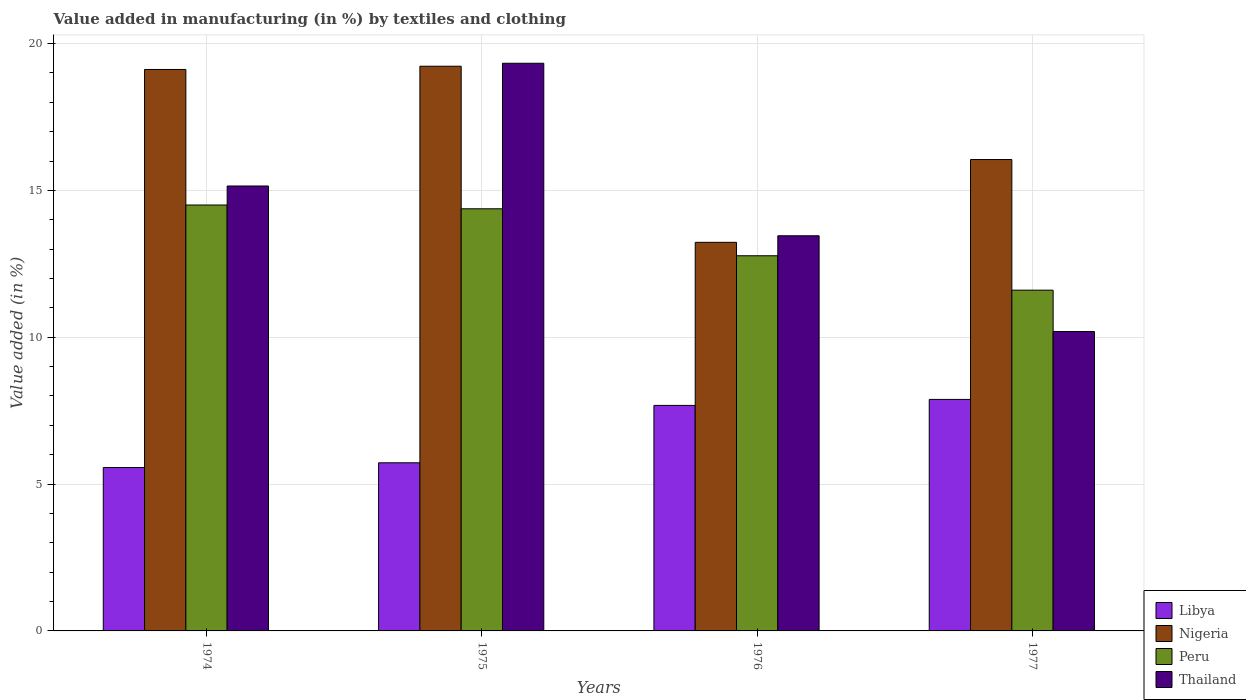How many bars are there on the 2nd tick from the left?
Provide a succinct answer. 4. How many bars are there on the 4th tick from the right?
Make the answer very short. 4. What is the label of the 1st group of bars from the left?
Offer a very short reply. 1974. In how many cases, is the number of bars for a given year not equal to the number of legend labels?
Your answer should be very brief. 0. What is the percentage of value added in manufacturing by textiles and clothing in Nigeria in 1974?
Your answer should be compact. 19.12. Across all years, what is the maximum percentage of value added in manufacturing by textiles and clothing in Thailand?
Your response must be concise. 19.33. Across all years, what is the minimum percentage of value added in manufacturing by textiles and clothing in Libya?
Offer a very short reply. 5.56. In which year was the percentage of value added in manufacturing by textiles and clothing in Nigeria maximum?
Provide a short and direct response. 1975. In which year was the percentage of value added in manufacturing by textiles and clothing in Nigeria minimum?
Your answer should be very brief. 1976. What is the total percentage of value added in manufacturing by textiles and clothing in Nigeria in the graph?
Provide a succinct answer. 67.63. What is the difference between the percentage of value added in manufacturing by textiles and clothing in Thailand in 1976 and that in 1977?
Your response must be concise. 3.26. What is the difference between the percentage of value added in manufacturing by textiles and clothing in Thailand in 1977 and the percentage of value added in manufacturing by textiles and clothing in Libya in 1975?
Provide a succinct answer. 4.47. What is the average percentage of value added in manufacturing by textiles and clothing in Thailand per year?
Keep it short and to the point. 14.53. In the year 1976, what is the difference between the percentage of value added in manufacturing by textiles and clothing in Peru and percentage of value added in manufacturing by textiles and clothing in Nigeria?
Offer a terse response. -0.46. What is the ratio of the percentage of value added in manufacturing by textiles and clothing in Nigeria in 1976 to that in 1977?
Your answer should be very brief. 0.82. Is the percentage of value added in manufacturing by textiles and clothing in Peru in 1975 less than that in 1977?
Offer a terse response. No. What is the difference between the highest and the second highest percentage of value added in manufacturing by textiles and clothing in Thailand?
Give a very brief answer. 4.18. What is the difference between the highest and the lowest percentage of value added in manufacturing by textiles and clothing in Peru?
Make the answer very short. 2.9. In how many years, is the percentage of value added in manufacturing by textiles and clothing in Peru greater than the average percentage of value added in manufacturing by textiles and clothing in Peru taken over all years?
Your answer should be compact. 2. Is it the case that in every year, the sum of the percentage of value added in manufacturing by textiles and clothing in Thailand and percentage of value added in manufacturing by textiles and clothing in Peru is greater than the sum of percentage of value added in manufacturing by textiles and clothing in Libya and percentage of value added in manufacturing by textiles and clothing in Nigeria?
Your answer should be compact. No. What does the 4th bar from the left in 1977 represents?
Offer a terse response. Thailand. What does the 2nd bar from the right in 1974 represents?
Your answer should be very brief. Peru. Are all the bars in the graph horizontal?
Provide a short and direct response. No. How many years are there in the graph?
Make the answer very short. 4. Are the values on the major ticks of Y-axis written in scientific E-notation?
Your response must be concise. No. Does the graph contain grids?
Your answer should be very brief. Yes. How are the legend labels stacked?
Make the answer very short. Vertical. What is the title of the graph?
Provide a short and direct response. Value added in manufacturing (in %) by textiles and clothing. What is the label or title of the Y-axis?
Your answer should be compact. Value added (in %). What is the Value added (in %) in Libya in 1974?
Ensure brevity in your answer.  5.56. What is the Value added (in %) in Nigeria in 1974?
Your answer should be very brief. 19.12. What is the Value added (in %) in Peru in 1974?
Keep it short and to the point. 14.5. What is the Value added (in %) of Thailand in 1974?
Ensure brevity in your answer.  15.15. What is the Value added (in %) of Libya in 1975?
Ensure brevity in your answer.  5.73. What is the Value added (in %) of Nigeria in 1975?
Give a very brief answer. 19.23. What is the Value added (in %) in Peru in 1975?
Keep it short and to the point. 14.38. What is the Value added (in %) of Thailand in 1975?
Your answer should be compact. 19.33. What is the Value added (in %) in Libya in 1976?
Offer a terse response. 7.68. What is the Value added (in %) in Nigeria in 1976?
Offer a very short reply. 13.23. What is the Value added (in %) of Peru in 1976?
Make the answer very short. 12.78. What is the Value added (in %) in Thailand in 1976?
Keep it short and to the point. 13.46. What is the Value added (in %) in Libya in 1977?
Keep it short and to the point. 7.88. What is the Value added (in %) in Nigeria in 1977?
Keep it short and to the point. 16.05. What is the Value added (in %) of Peru in 1977?
Provide a short and direct response. 11.6. What is the Value added (in %) of Thailand in 1977?
Provide a succinct answer. 10.2. Across all years, what is the maximum Value added (in %) of Libya?
Offer a very short reply. 7.88. Across all years, what is the maximum Value added (in %) in Nigeria?
Provide a succinct answer. 19.23. Across all years, what is the maximum Value added (in %) of Peru?
Ensure brevity in your answer.  14.5. Across all years, what is the maximum Value added (in %) in Thailand?
Your response must be concise. 19.33. Across all years, what is the minimum Value added (in %) in Libya?
Offer a terse response. 5.56. Across all years, what is the minimum Value added (in %) of Nigeria?
Ensure brevity in your answer.  13.23. Across all years, what is the minimum Value added (in %) in Peru?
Make the answer very short. 11.6. Across all years, what is the minimum Value added (in %) of Thailand?
Provide a short and direct response. 10.2. What is the total Value added (in %) of Libya in the graph?
Give a very brief answer. 26.85. What is the total Value added (in %) of Nigeria in the graph?
Offer a very short reply. 67.63. What is the total Value added (in %) in Peru in the graph?
Keep it short and to the point. 53.26. What is the total Value added (in %) in Thailand in the graph?
Ensure brevity in your answer.  58.13. What is the difference between the Value added (in %) of Libya in 1974 and that in 1975?
Provide a short and direct response. -0.16. What is the difference between the Value added (in %) in Nigeria in 1974 and that in 1975?
Your response must be concise. -0.11. What is the difference between the Value added (in %) of Peru in 1974 and that in 1975?
Keep it short and to the point. 0.13. What is the difference between the Value added (in %) in Thailand in 1974 and that in 1975?
Give a very brief answer. -4.18. What is the difference between the Value added (in %) in Libya in 1974 and that in 1976?
Ensure brevity in your answer.  -2.12. What is the difference between the Value added (in %) of Nigeria in 1974 and that in 1976?
Your answer should be compact. 5.89. What is the difference between the Value added (in %) in Peru in 1974 and that in 1976?
Give a very brief answer. 1.73. What is the difference between the Value added (in %) in Thailand in 1974 and that in 1976?
Offer a terse response. 1.7. What is the difference between the Value added (in %) of Libya in 1974 and that in 1977?
Make the answer very short. -2.32. What is the difference between the Value added (in %) of Nigeria in 1974 and that in 1977?
Offer a terse response. 3.07. What is the difference between the Value added (in %) of Peru in 1974 and that in 1977?
Your response must be concise. 2.9. What is the difference between the Value added (in %) in Thailand in 1974 and that in 1977?
Your answer should be very brief. 4.96. What is the difference between the Value added (in %) in Libya in 1975 and that in 1976?
Your response must be concise. -1.95. What is the difference between the Value added (in %) of Nigeria in 1975 and that in 1976?
Your answer should be compact. 6. What is the difference between the Value added (in %) in Peru in 1975 and that in 1976?
Provide a short and direct response. 1.6. What is the difference between the Value added (in %) of Thailand in 1975 and that in 1976?
Give a very brief answer. 5.87. What is the difference between the Value added (in %) of Libya in 1975 and that in 1977?
Offer a very short reply. -2.16. What is the difference between the Value added (in %) in Nigeria in 1975 and that in 1977?
Make the answer very short. 3.18. What is the difference between the Value added (in %) of Peru in 1975 and that in 1977?
Provide a short and direct response. 2.77. What is the difference between the Value added (in %) of Thailand in 1975 and that in 1977?
Offer a very short reply. 9.14. What is the difference between the Value added (in %) of Libya in 1976 and that in 1977?
Provide a succinct answer. -0.2. What is the difference between the Value added (in %) of Nigeria in 1976 and that in 1977?
Make the answer very short. -2.82. What is the difference between the Value added (in %) of Peru in 1976 and that in 1977?
Give a very brief answer. 1.17. What is the difference between the Value added (in %) in Thailand in 1976 and that in 1977?
Ensure brevity in your answer.  3.26. What is the difference between the Value added (in %) of Libya in 1974 and the Value added (in %) of Nigeria in 1975?
Provide a succinct answer. -13.67. What is the difference between the Value added (in %) in Libya in 1974 and the Value added (in %) in Peru in 1975?
Your response must be concise. -8.81. What is the difference between the Value added (in %) of Libya in 1974 and the Value added (in %) of Thailand in 1975?
Offer a terse response. -13.77. What is the difference between the Value added (in %) in Nigeria in 1974 and the Value added (in %) in Peru in 1975?
Offer a terse response. 4.74. What is the difference between the Value added (in %) of Nigeria in 1974 and the Value added (in %) of Thailand in 1975?
Offer a terse response. -0.21. What is the difference between the Value added (in %) of Peru in 1974 and the Value added (in %) of Thailand in 1975?
Ensure brevity in your answer.  -4.83. What is the difference between the Value added (in %) in Libya in 1974 and the Value added (in %) in Nigeria in 1976?
Provide a succinct answer. -7.67. What is the difference between the Value added (in %) of Libya in 1974 and the Value added (in %) of Peru in 1976?
Offer a terse response. -7.21. What is the difference between the Value added (in %) of Libya in 1974 and the Value added (in %) of Thailand in 1976?
Your answer should be very brief. -7.89. What is the difference between the Value added (in %) in Nigeria in 1974 and the Value added (in %) in Peru in 1976?
Offer a very short reply. 6.34. What is the difference between the Value added (in %) of Nigeria in 1974 and the Value added (in %) of Thailand in 1976?
Keep it short and to the point. 5.66. What is the difference between the Value added (in %) of Peru in 1974 and the Value added (in %) of Thailand in 1976?
Provide a short and direct response. 1.05. What is the difference between the Value added (in %) in Libya in 1974 and the Value added (in %) in Nigeria in 1977?
Give a very brief answer. -10.49. What is the difference between the Value added (in %) of Libya in 1974 and the Value added (in %) of Peru in 1977?
Provide a succinct answer. -6.04. What is the difference between the Value added (in %) of Libya in 1974 and the Value added (in %) of Thailand in 1977?
Ensure brevity in your answer.  -4.63. What is the difference between the Value added (in %) of Nigeria in 1974 and the Value added (in %) of Peru in 1977?
Your answer should be very brief. 7.52. What is the difference between the Value added (in %) of Nigeria in 1974 and the Value added (in %) of Thailand in 1977?
Make the answer very short. 8.92. What is the difference between the Value added (in %) in Peru in 1974 and the Value added (in %) in Thailand in 1977?
Your answer should be very brief. 4.31. What is the difference between the Value added (in %) of Libya in 1975 and the Value added (in %) of Nigeria in 1976?
Ensure brevity in your answer.  -7.51. What is the difference between the Value added (in %) in Libya in 1975 and the Value added (in %) in Peru in 1976?
Offer a terse response. -7.05. What is the difference between the Value added (in %) in Libya in 1975 and the Value added (in %) in Thailand in 1976?
Provide a succinct answer. -7.73. What is the difference between the Value added (in %) in Nigeria in 1975 and the Value added (in %) in Peru in 1976?
Your response must be concise. 6.45. What is the difference between the Value added (in %) in Nigeria in 1975 and the Value added (in %) in Thailand in 1976?
Offer a very short reply. 5.77. What is the difference between the Value added (in %) in Peru in 1975 and the Value added (in %) in Thailand in 1976?
Offer a very short reply. 0.92. What is the difference between the Value added (in %) in Libya in 1975 and the Value added (in %) in Nigeria in 1977?
Offer a terse response. -10.33. What is the difference between the Value added (in %) of Libya in 1975 and the Value added (in %) of Peru in 1977?
Make the answer very short. -5.88. What is the difference between the Value added (in %) of Libya in 1975 and the Value added (in %) of Thailand in 1977?
Offer a very short reply. -4.47. What is the difference between the Value added (in %) of Nigeria in 1975 and the Value added (in %) of Peru in 1977?
Give a very brief answer. 7.63. What is the difference between the Value added (in %) in Nigeria in 1975 and the Value added (in %) in Thailand in 1977?
Your response must be concise. 9.03. What is the difference between the Value added (in %) of Peru in 1975 and the Value added (in %) of Thailand in 1977?
Offer a terse response. 4.18. What is the difference between the Value added (in %) in Libya in 1976 and the Value added (in %) in Nigeria in 1977?
Your response must be concise. -8.37. What is the difference between the Value added (in %) of Libya in 1976 and the Value added (in %) of Peru in 1977?
Give a very brief answer. -3.92. What is the difference between the Value added (in %) in Libya in 1976 and the Value added (in %) in Thailand in 1977?
Keep it short and to the point. -2.52. What is the difference between the Value added (in %) of Nigeria in 1976 and the Value added (in %) of Peru in 1977?
Offer a terse response. 1.63. What is the difference between the Value added (in %) in Nigeria in 1976 and the Value added (in %) in Thailand in 1977?
Keep it short and to the point. 3.04. What is the difference between the Value added (in %) of Peru in 1976 and the Value added (in %) of Thailand in 1977?
Ensure brevity in your answer.  2.58. What is the average Value added (in %) of Libya per year?
Keep it short and to the point. 6.71. What is the average Value added (in %) of Nigeria per year?
Provide a succinct answer. 16.91. What is the average Value added (in %) in Peru per year?
Your answer should be very brief. 13.31. What is the average Value added (in %) of Thailand per year?
Offer a very short reply. 14.53. In the year 1974, what is the difference between the Value added (in %) in Libya and Value added (in %) in Nigeria?
Provide a short and direct response. -13.56. In the year 1974, what is the difference between the Value added (in %) of Libya and Value added (in %) of Peru?
Offer a terse response. -8.94. In the year 1974, what is the difference between the Value added (in %) in Libya and Value added (in %) in Thailand?
Ensure brevity in your answer.  -9.59. In the year 1974, what is the difference between the Value added (in %) of Nigeria and Value added (in %) of Peru?
Your answer should be compact. 4.62. In the year 1974, what is the difference between the Value added (in %) of Nigeria and Value added (in %) of Thailand?
Provide a succinct answer. 3.97. In the year 1974, what is the difference between the Value added (in %) in Peru and Value added (in %) in Thailand?
Provide a succinct answer. -0.65. In the year 1975, what is the difference between the Value added (in %) of Libya and Value added (in %) of Nigeria?
Provide a short and direct response. -13.5. In the year 1975, what is the difference between the Value added (in %) in Libya and Value added (in %) in Peru?
Your response must be concise. -8.65. In the year 1975, what is the difference between the Value added (in %) in Libya and Value added (in %) in Thailand?
Keep it short and to the point. -13.61. In the year 1975, what is the difference between the Value added (in %) in Nigeria and Value added (in %) in Peru?
Your response must be concise. 4.85. In the year 1975, what is the difference between the Value added (in %) in Nigeria and Value added (in %) in Thailand?
Keep it short and to the point. -0.1. In the year 1975, what is the difference between the Value added (in %) in Peru and Value added (in %) in Thailand?
Your response must be concise. -4.96. In the year 1976, what is the difference between the Value added (in %) in Libya and Value added (in %) in Nigeria?
Provide a short and direct response. -5.55. In the year 1976, what is the difference between the Value added (in %) in Libya and Value added (in %) in Peru?
Offer a very short reply. -5.1. In the year 1976, what is the difference between the Value added (in %) in Libya and Value added (in %) in Thailand?
Give a very brief answer. -5.78. In the year 1976, what is the difference between the Value added (in %) of Nigeria and Value added (in %) of Peru?
Offer a terse response. 0.46. In the year 1976, what is the difference between the Value added (in %) of Nigeria and Value added (in %) of Thailand?
Make the answer very short. -0.22. In the year 1976, what is the difference between the Value added (in %) in Peru and Value added (in %) in Thailand?
Provide a succinct answer. -0.68. In the year 1977, what is the difference between the Value added (in %) in Libya and Value added (in %) in Nigeria?
Provide a short and direct response. -8.17. In the year 1977, what is the difference between the Value added (in %) of Libya and Value added (in %) of Peru?
Your answer should be compact. -3.72. In the year 1977, what is the difference between the Value added (in %) in Libya and Value added (in %) in Thailand?
Your answer should be compact. -2.31. In the year 1977, what is the difference between the Value added (in %) in Nigeria and Value added (in %) in Peru?
Make the answer very short. 4.45. In the year 1977, what is the difference between the Value added (in %) of Nigeria and Value added (in %) of Thailand?
Your answer should be compact. 5.86. In the year 1977, what is the difference between the Value added (in %) of Peru and Value added (in %) of Thailand?
Keep it short and to the point. 1.41. What is the ratio of the Value added (in %) of Libya in 1974 to that in 1975?
Provide a succinct answer. 0.97. What is the ratio of the Value added (in %) in Peru in 1974 to that in 1975?
Offer a terse response. 1.01. What is the ratio of the Value added (in %) of Thailand in 1974 to that in 1975?
Provide a succinct answer. 0.78. What is the ratio of the Value added (in %) of Libya in 1974 to that in 1976?
Provide a succinct answer. 0.72. What is the ratio of the Value added (in %) of Nigeria in 1974 to that in 1976?
Offer a very short reply. 1.44. What is the ratio of the Value added (in %) in Peru in 1974 to that in 1976?
Your answer should be compact. 1.14. What is the ratio of the Value added (in %) of Thailand in 1974 to that in 1976?
Give a very brief answer. 1.13. What is the ratio of the Value added (in %) of Libya in 1974 to that in 1977?
Ensure brevity in your answer.  0.71. What is the ratio of the Value added (in %) in Nigeria in 1974 to that in 1977?
Provide a succinct answer. 1.19. What is the ratio of the Value added (in %) in Peru in 1974 to that in 1977?
Ensure brevity in your answer.  1.25. What is the ratio of the Value added (in %) of Thailand in 1974 to that in 1977?
Ensure brevity in your answer.  1.49. What is the ratio of the Value added (in %) of Libya in 1975 to that in 1976?
Your response must be concise. 0.75. What is the ratio of the Value added (in %) of Nigeria in 1975 to that in 1976?
Your answer should be compact. 1.45. What is the ratio of the Value added (in %) of Peru in 1975 to that in 1976?
Offer a very short reply. 1.13. What is the ratio of the Value added (in %) of Thailand in 1975 to that in 1976?
Provide a short and direct response. 1.44. What is the ratio of the Value added (in %) of Libya in 1975 to that in 1977?
Offer a terse response. 0.73. What is the ratio of the Value added (in %) of Nigeria in 1975 to that in 1977?
Your response must be concise. 1.2. What is the ratio of the Value added (in %) in Peru in 1975 to that in 1977?
Give a very brief answer. 1.24. What is the ratio of the Value added (in %) in Thailand in 1975 to that in 1977?
Offer a terse response. 1.9. What is the ratio of the Value added (in %) in Libya in 1976 to that in 1977?
Provide a succinct answer. 0.97. What is the ratio of the Value added (in %) of Nigeria in 1976 to that in 1977?
Offer a very short reply. 0.82. What is the ratio of the Value added (in %) in Peru in 1976 to that in 1977?
Your response must be concise. 1.1. What is the ratio of the Value added (in %) in Thailand in 1976 to that in 1977?
Provide a short and direct response. 1.32. What is the difference between the highest and the second highest Value added (in %) of Libya?
Offer a very short reply. 0.2. What is the difference between the highest and the second highest Value added (in %) in Nigeria?
Provide a succinct answer. 0.11. What is the difference between the highest and the second highest Value added (in %) of Peru?
Your answer should be compact. 0.13. What is the difference between the highest and the second highest Value added (in %) in Thailand?
Keep it short and to the point. 4.18. What is the difference between the highest and the lowest Value added (in %) of Libya?
Your response must be concise. 2.32. What is the difference between the highest and the lowest Value added (in %) of Nigeria?
Provide a short and direct response. 6. What is the difference between the highest and the lowest Value added (in %) of Peru?
Make the answer very short. 2.9. What is the difference between the highest and the lowest Value added (in %) of Thailand?
Make the answer very short. 9.14. 